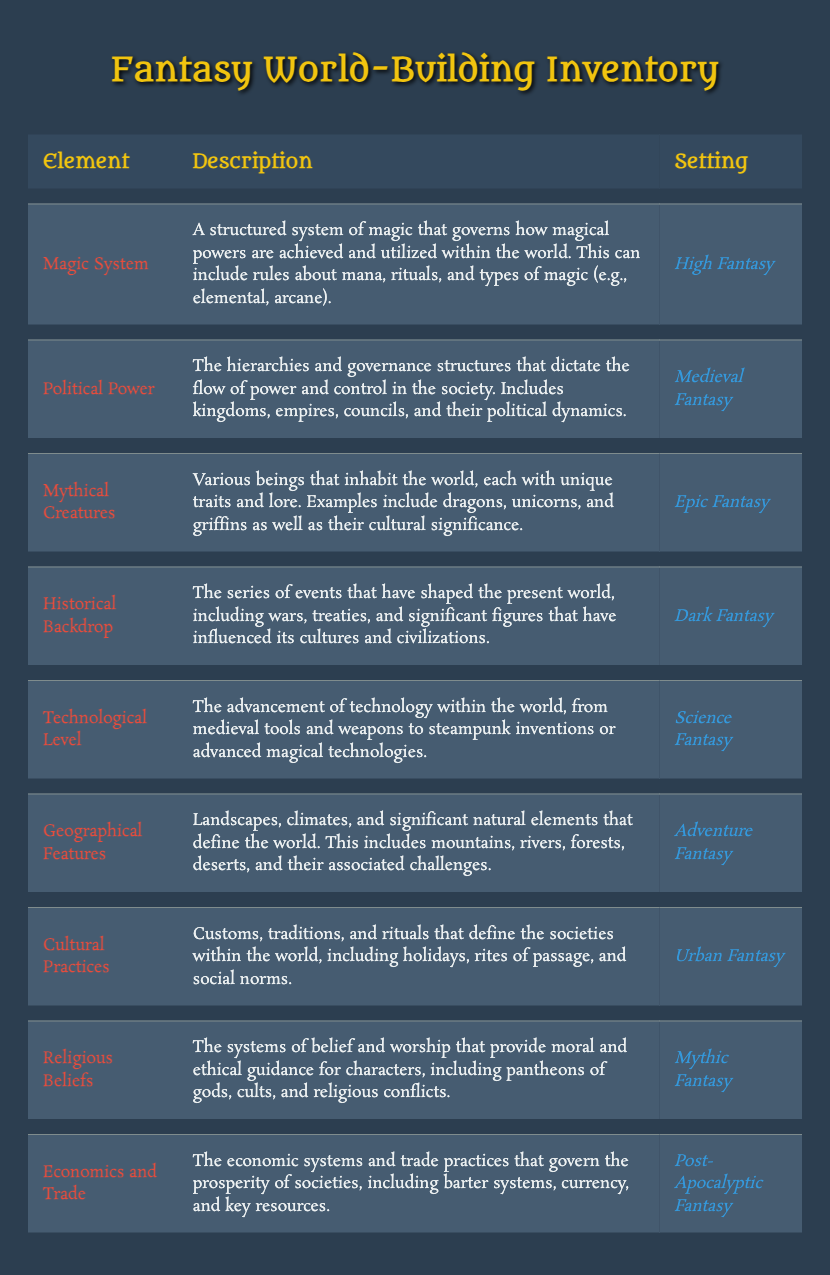What element describes a structured system of magic? The table lists the "Magic System" under the Element column. It is described as a structured system of magic that governs how magical powers are achieved and utilized within the world.
Answer: Magic System Which setting features "Technological Level" as an element? In the table, the setting associated with "Technological Level" is "Science Fantasy." This is found directly in the corresponding row for the element.
Answer: Science Fantasy Does "Cultural Practices" exist in the table? Yes, "Cultural Practices" is listed as one of the elements in the inventory, confirming its existence.
Answer: Yes What type of fantasy has "Economics and Trade" as its element? The table shows that "Economics and Trade" is categorized under "Post-Apocalyptic Fantasy." This information can be found by looking at the respective row.
Answer: Post-Apocalyptic Fantasy How many settings contain a mention of "Magic System" or "Mythical Creatures"? Both "Magic System" and "Mythical Creatures" are unique elements in the table. Their respective settings are "High Fantasy" and "Epic Fantasy." Therefore, adding both gives us a total of two.
Answer: 2 Which element is related to battles, treaties, and significant figures? The element that relates to battles, treaties, and significant figures is "Historical Backdrop." It specifically addresses events that have shaped the present world and is found in the Dark Fantasy setting.
Answer: Historical Backdrop Are there more settings associated with economic systems than with magical systems? To determine this, we check the table: "Economics and Trade" is listed under Post-Apocalyptic Fantasy (1 setting), while "Magic System" is listed under High Fantasy (1 setting). Since both have only one setting, they are equal.
Answer: No What is the relationship between "Cultural Practices" and its setting? "Cultural Practices" is related to the "Urban Fantasy" setting, indicating that these customs and traditions are specifically tied to urban environments within that genre.
Answer: Urban Fantasy Identify the element related to the advancement of technology, and name its setting. The table describes "Technological Level" as the element related to technology, and its setting is "Science Fantasy." This can be directly found in the respective row.
Answer: Technological Level, Science Fantasy 